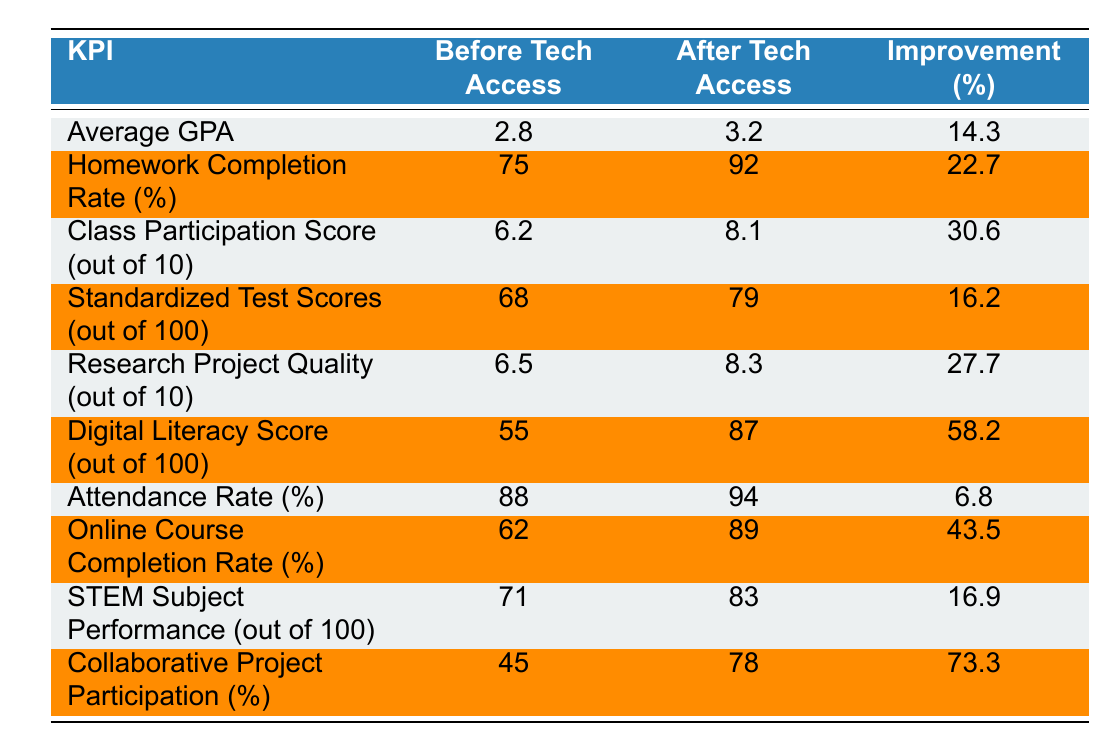What is the improvement percentage for the Average GPA after receiving technology access? The Average GPA before tech access was 2.8, and after tech access, it rose to 3.2. The improvement percentage is calculated as ((3.2 - 2.8) / 2.8) * 100, which is 14.3%.
Answer: 14.3% What was the Homework Completion Rate before tech access? According to the table, the Homework Completion Rate before tech access was 75%.
Answer: 75% What is the difference in the Class Participation Score before and after tech access? The Class Participation Score before tech access was 6.2, and after tech access, it increased to 8.1. The difference is calculated as 8.1 - 6.2 = 1.9.
Answer: 1.9 Did the Digital Literacy Score increase by more than 50%? The Digital Literacy Score improved from 55 to 87. The improvement percentage is ((87 - 55) / 55) * 100 = 58.2%, which is more than 50%.
Answer: Yes What is the average improvement percentage of all KPIs listed in the table? To calculate the average improvement percentage, sum all improvement percentages: 14.3 + 22.7 + 30.6 + 16.2 + 27.7 + 58.2 + 6.8 + 43.5 + 16.9 + 73.3 = 339.2. There are 10 KPIs, so the average is 339.2 / 10 = 33.92%.
Answer: 33.92% Which KPI showed the highest improvement percentage and what was it? The Collaborative Project Participation showed the highest improvement percentage, with an increase from 45% to 78%, resulting in a 73.3% improvement.
Answer: 73.3% What is the attendance rate after receiving technology access? The attendance rate after receiving technology access is stated in the table as 94%.
Answer: 94% Is the Research Project Quality score above 8 after the technology access? The Research Project Quality score after tech access is 8.3, which is above 8.
Answer: Yes Which KPI had the lowest improvement percentage and what was that percentage? The Attendance Rate had the lowest improvement percentage at 6.8%.
Answer: 6.8% What was the total improvement in the completion rates of Homework and Online Courses combined? The Homework Completion Rate improved by 22.7%, and the Online Course Completion Rate improved by 43.5%. The combined improvement is 22.7 + 43.5 = 66.2%.
Answer: 66.2% How much did the Standardized Test Scores improve numerically? The Standardized Test Scores increased from 68 to 79, resulting in a numerical improvement of 79 - 68 = 11.
Answer: 11 